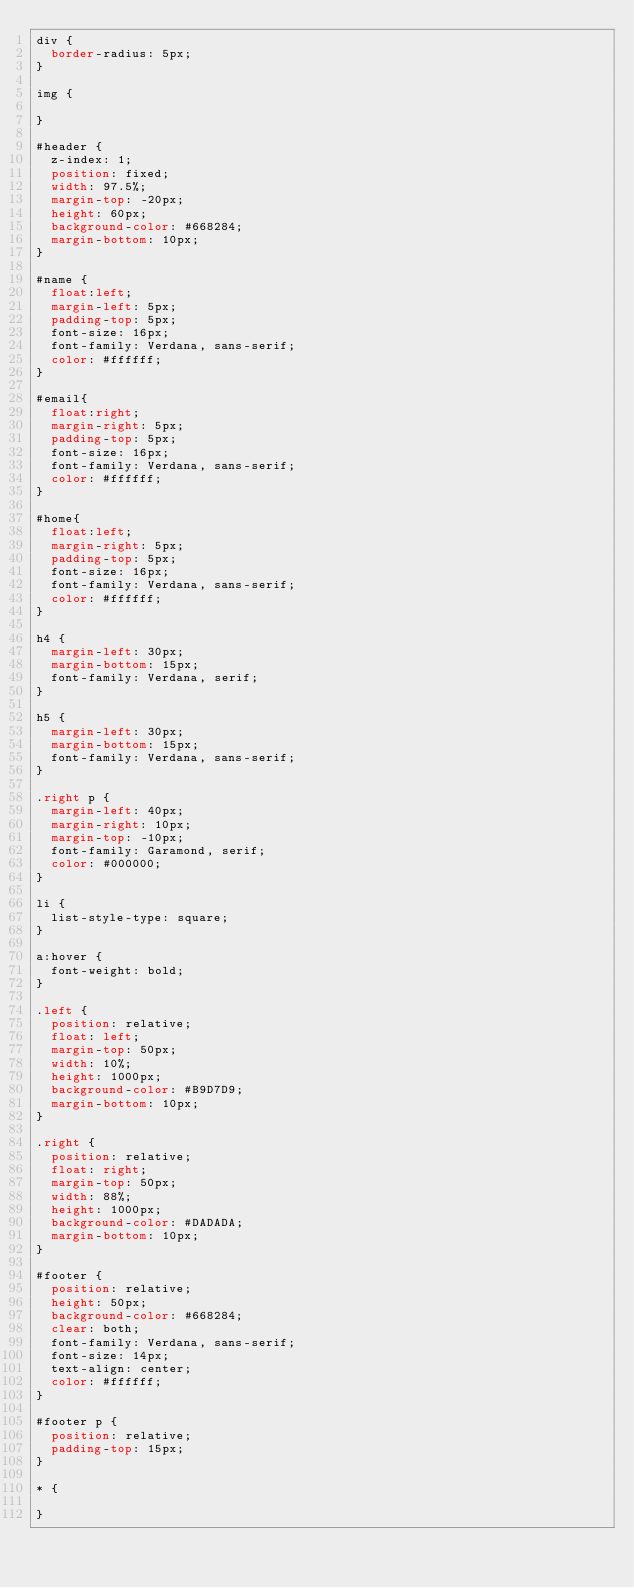Convert code to text. <code><loc_0><loc_0><loc_500><loc_500><_CSS_>div {
	border-radius: 5px;
}

img {

}

#header {
	z-index: 1;
	position: fixed;
	width: 97.5%;
	margin-top: -20px;
	height: 60px;
	background-color: #668284;
	margin-bottom: 10px;
}

#name {
	float:left;
	margin-left: 5px;
	padding-top: 5px;
	font-size: 16px;
	font-family: Verdana, sans-serif;
	color: #ffffff;
}

#email{
	float:right;
	margin-right: 5px;
	padding-top: 5px;
	font-size: 16px;
	font-family: Verdana, sans-serif;
	color: #ffffff;
}

#home{
	float:left;
	margin-right: 5px;
	padding-top: 5px;
	font-size: 16px;
	font-family: Verdana, sans-serif;
	color: #ffffff;
}

h4 {
	margin-left: 30px;
	margin-bottom: 15px;
	font-family: Verdana, serif;
}

h5 {
	margin-left: 30px;
	margin-bottom: 15px;
	font-family: Verdana, sans-serif;
}

.right p {
	margin-left: 40px;
	margin-right: 10px;
	margin-top: -10px;
	font-family: Garamond, serif;
	color: #000000;
}

li {
	list-style-type: square;
}

a:hover {
	font-weight: bold;
}

.left {
	position: relative;
	float: left;
	margin-top: 50px;
	width: 10%;
	height: 1000px;
	background-color: #B9D7D9;
	margin-bottom: 10px;
}

.right {
	position: relative;
	float: right;
	margin-top: 50px;
	width: 88%;
	height: 1000px;
	background-color: #DADADA;
	margin-bottom: 10px;
}

#footer {
	position: relative;
	height: 50px;
	background-color: #668284;
	clear: both;
	font-family: Verdana, sans-serif;
	font-size: 14px;
	text-align: center;
	color: #ffffff;
}

#footer p {
	position: relative;
	padding-top: 15px;
}

* {
	
}</code> 